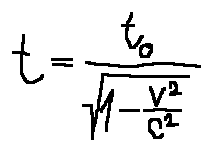Convert formula to latex. <formula><loc_0><loc_0><loc_500><loc_500>t = \frac { t _ { 0 } } { \sqrt { 1 - \frac { v ^ { 2 } } { c ^ { 2 } } } }</formula> 